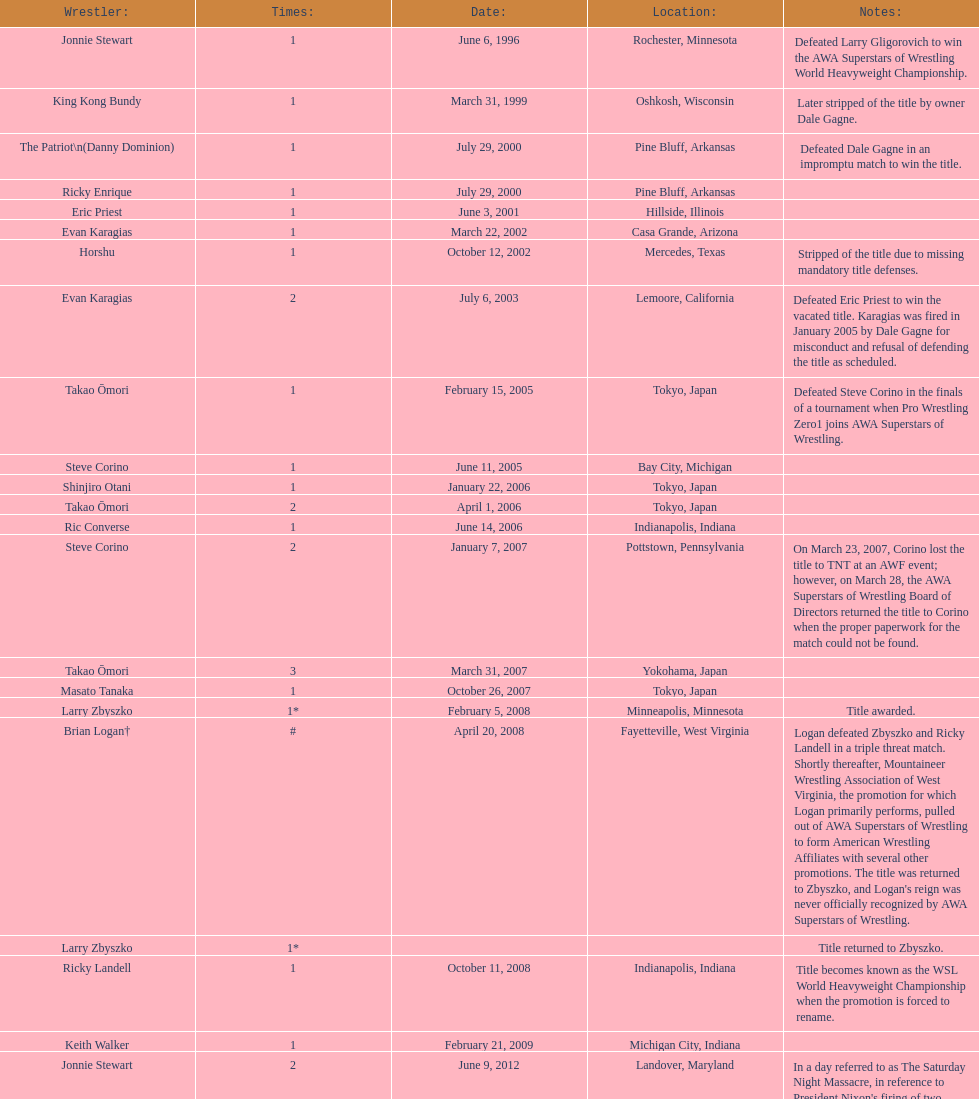How many unique men obtained the wsl crown before horshu claimed his first wsl championship? 6. 